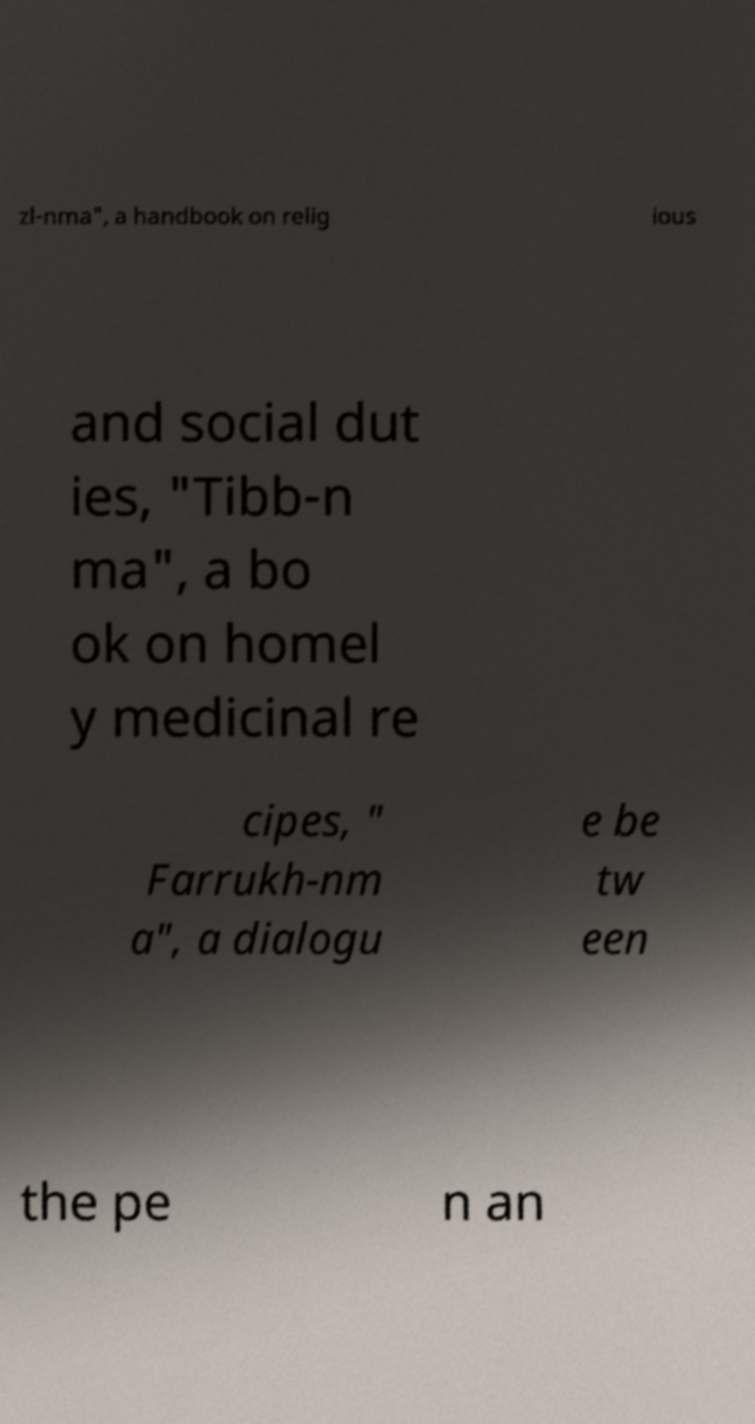Can you accurately transcribe the text from the provided image for me? zl-nma", a handbook on relig ious and social dut ies, "Tibb-n ma", a bo ok on homel y medicinal re cipes, " Farrukh-nm a", a dialogu e be tw een the pe n an 